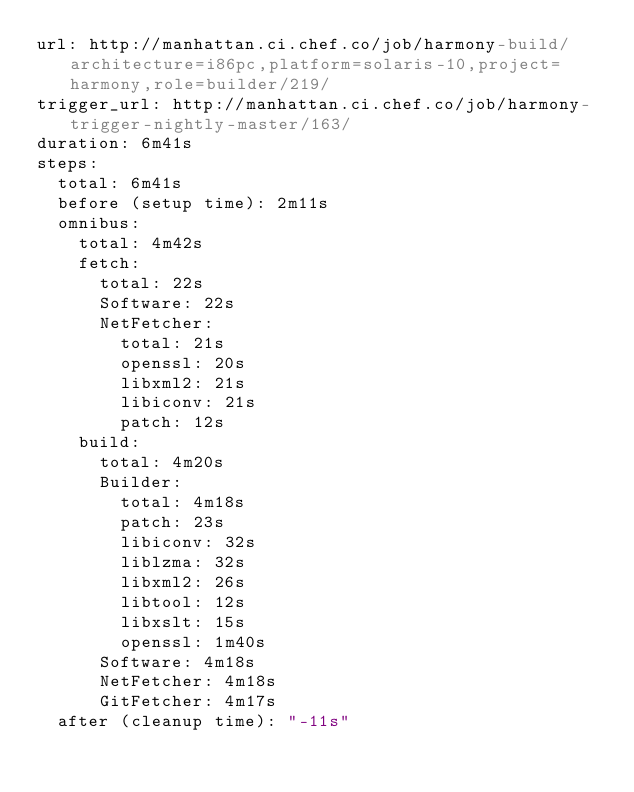Convert code to text. <code><loc_0><loc_0><loc_500><loc_500><_YAML_>url: http://manhattan.ci.chef.co/job/harmony-build/architecture=i86pc,platform=solaris-10,project=harmony,role=builder/219/
trigger_url: http://manhattan.ci.chef.co/job/harmony-trigger-nightly-master/163/
duration: 6m41s
steps:
  total: 6m41s
  before (setup time): 2m11s
  omnibus:
    total: 4m42s
    fetch:
      total: 22s
      Software: 22s
      NetFetcher:
        total: 21s
        openssl: 20s
        libxml2: 21s
        libiconv: 21s
        patch: 12s
    build:
      total: 4m20s
      Builder:
        total: 4m18s
        patch: 23s
        libiconv: 32s
        liblzma: 32s
        libxml2: 26s
        libtool: 12s
        libxslt: 15s
        openssl: 1m40s
      Software: 4m18s
      NetFetcher: 4m18s
      GitFetcher: 4m17s
  after (cleanup time): "-11s"
</code> 